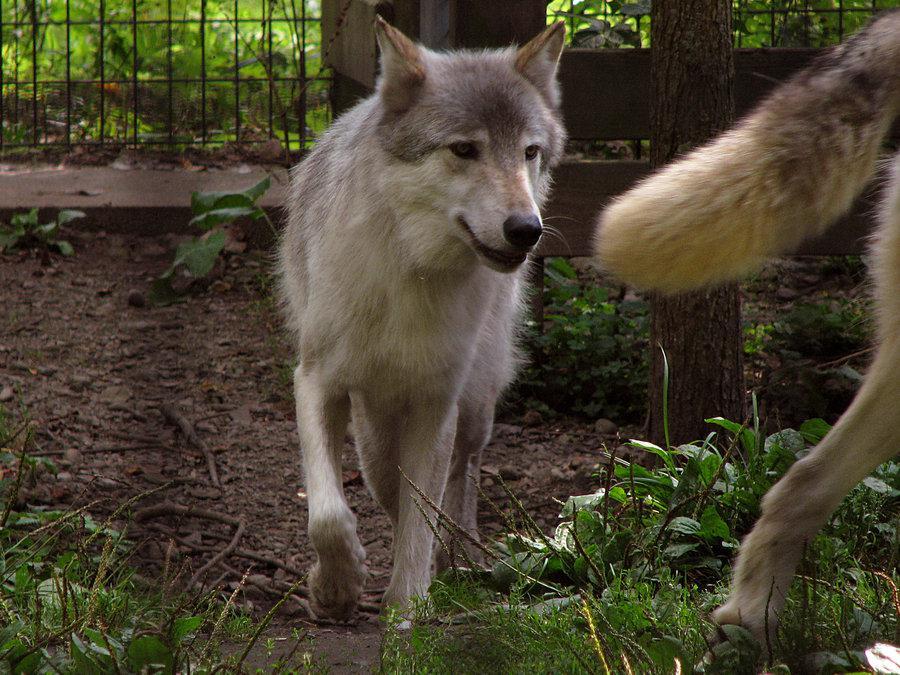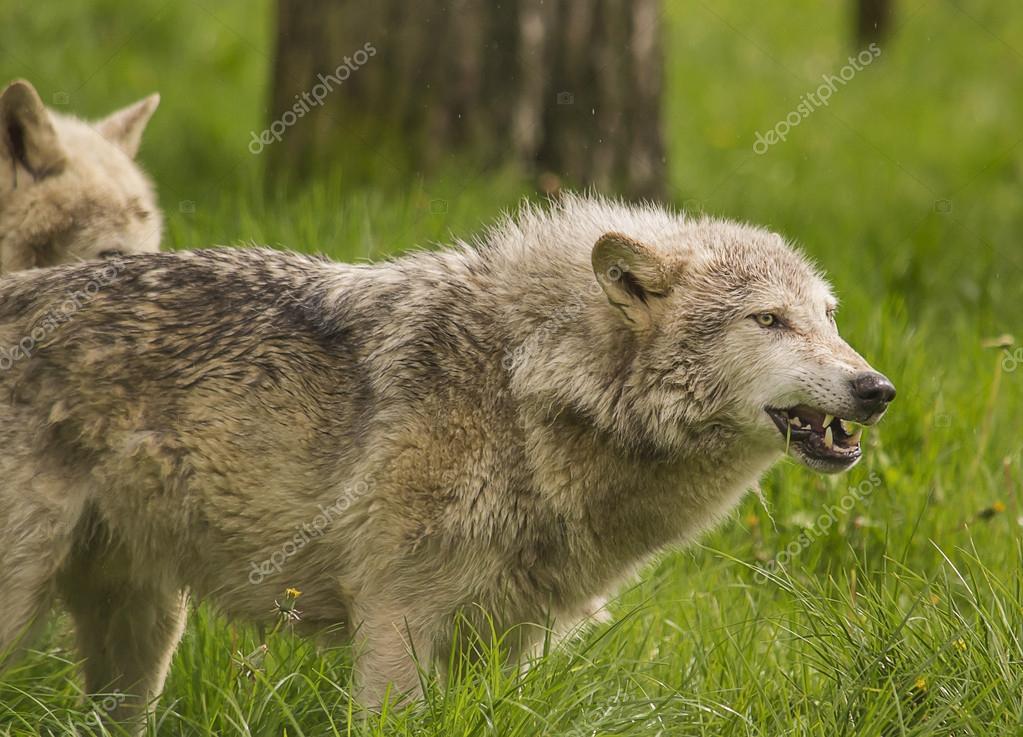The first image is the image on the left, the second image is the image on the right. Assess this claim about the two images: "In the left image, wire fence is visible behind the wolf.". Correct or not? Answer yes or no. Yes. The first image is the image on the left, the second image is the image on the right. Considering the images on both sides, is "There is a fence behind the animal in the image on the left." valid? Answer yes or no. Yes. 